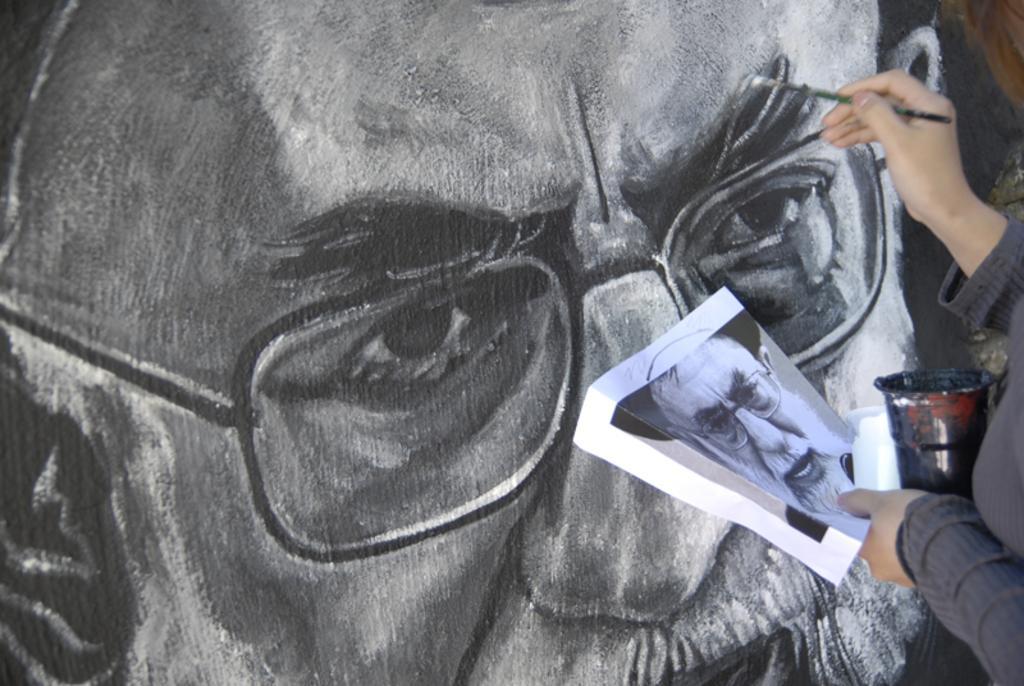Could you give a brief overview of what you see in this image? This image consists of a person holding a paper and a paint box is painting on the wall. In the front, we can see a picture of a man. 